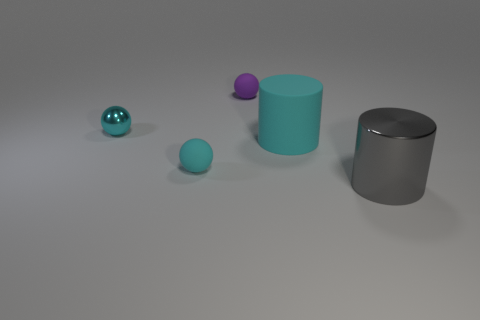Add 2 cyan matte things. How many objects exist? 7 Subtract all cylinders. How many objects are left? 3 Add 4 large gray objects. How many large gray objects exist? 5 Subtract 0 gray cubes. How many objects are left? 5 Subtract all cyan cylinders. Subtract all purple matte balls. How many objects are left? 3 Add 3 large rubber cylinders. How many large rubber cylinders are left? 4 